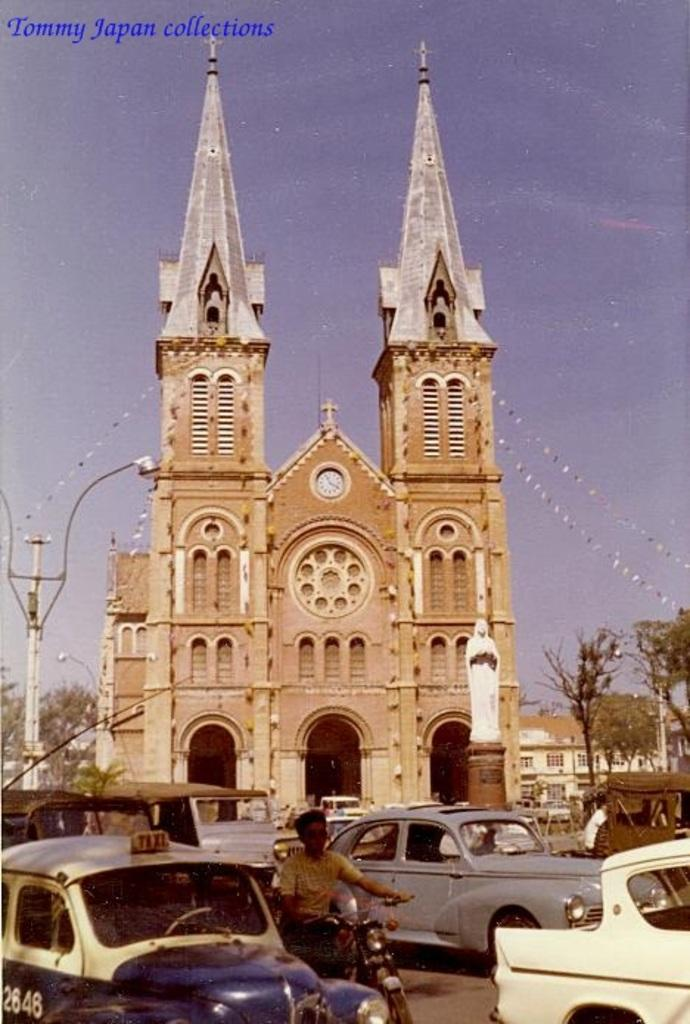What is located in the foreground of the image? There are vehicles in the foreground of the image. What can be seen behind the vehicles? There is architecture visible behind the vehicles. What type of natural elements are present in the image? Trees are present in the image. What type of man-made structure is visible in the image? There is a building in the image. How is the string used to distribute resources in the image? There is no string present in the image, and therefore no distribution of resources can be observed. 